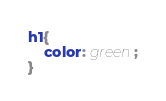Convert code to text. <code><loc_0><loc_0><loc_500><loc_500><_CSS_>h1{
	color: green;
}</code> 